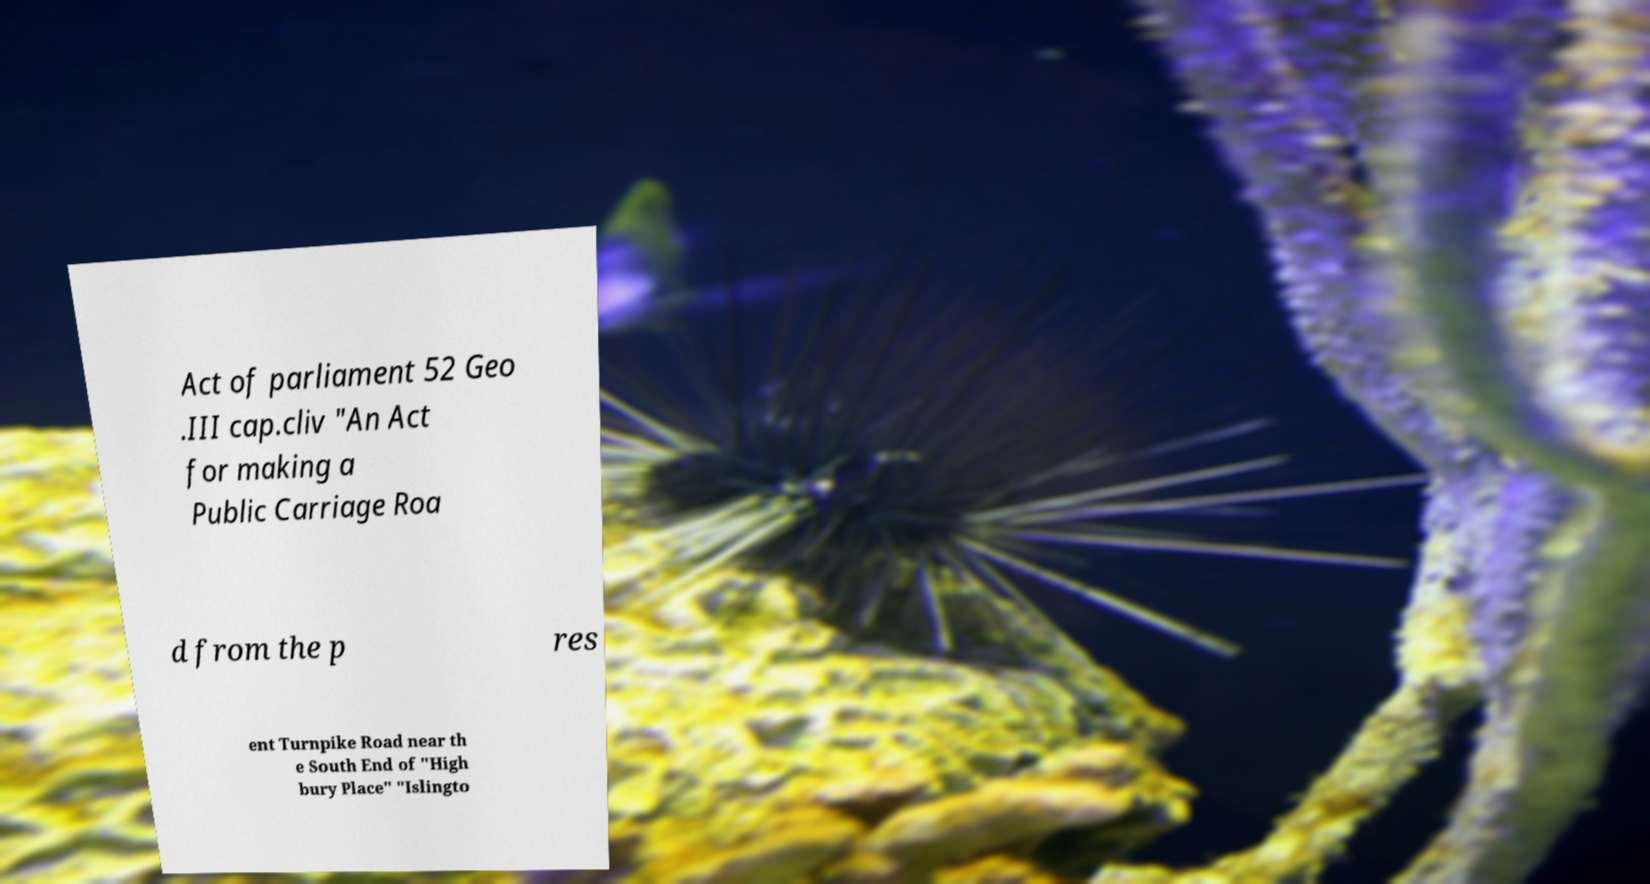Can you accurately transcribe the text from the provided image for me? Act of parliament 52 Geo .III cap.cliv "An Act for making a Public Carriage Roa d from the p res ent Turnpike Road near th e South End of "High bury Place" "Islingto 